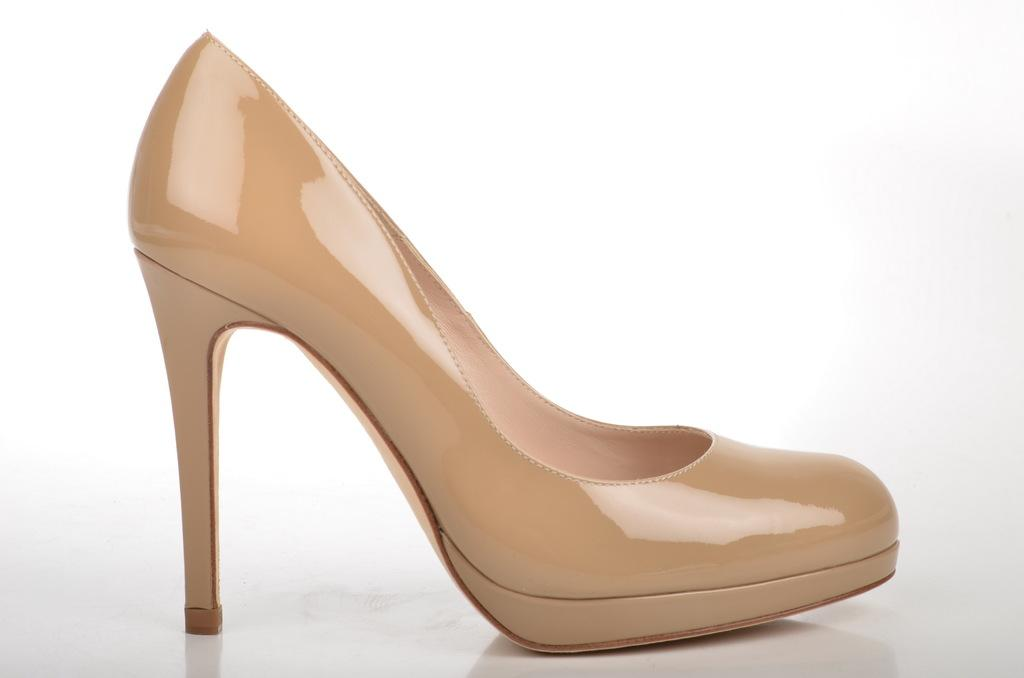What is on the ground in the image? There is footwear on the ground in the image. What color is the background of the image? The background of the image is white. How many nails can be seen in the image? There are no nails present in the image. What type of fruit is on the page in the image? There is no fruit or page present in the image. 